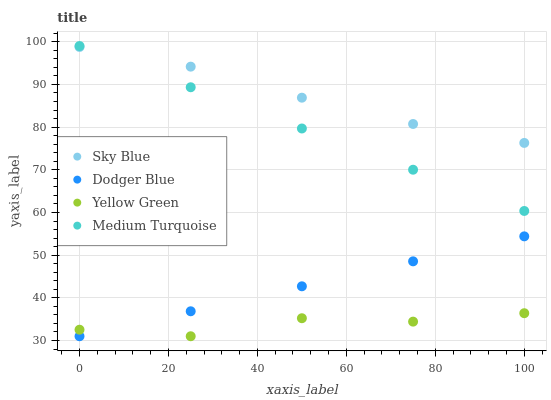Does Yellow Green have the minimum area under the curve?
Answer yes or no. Yes. Does Sky Blue have the maximum area under the curve?
Answer yes or no. Yes. Does Dodger Blue have the minimum area under the curve?
Answer yes or no. No. Does Dodger Blue have the maximum area under the curve?
Answer yes or no. No. Is Dodger Blue the smoothest?
Answer yes or no. Yes. Is Yellow Green the roughest?
Answer yes or no. Yes. Is Yellow Green the smoothest?
Answer yes or no. No. Is Dodger Blue the roughest?
Answer yes or no. No. Does Dodger Blue have the lowest value?
Answer yes or no. Yes. Does Medium Turquoise have the lowest value?
Answer yes or no. No. Does Medium Turquoise have the highest value?
Answer yes or no. Yes. Does Dodger Blue have the highest value?
Answer yes or no. No. Is Yellow Green less than Medium Turquoise?
Answer yes or no. Yes. Is Medium Turquoise greater than Dodger Blue?
Answer yes or no. Yes. Does Sky Blue intersect Medium Turquoise?
Answer yes or no. Yes. Is Sky Blue less than Medium Turquoise?
Answer yes or no. No. Is Sky Blue greater than Medium Turquoise?
Answer yes or no. No. Does Yellow Green intersect Medium Turquoise?
Answer yes or no. No. 